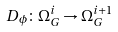<formula> <loc_0><loc_0><loc_500><loc_500>D _ { \phi } \colon \Omega _ { G } ^ { i } \rightarrow \Omega _ { G } ^ { i + 1 }</formula> 